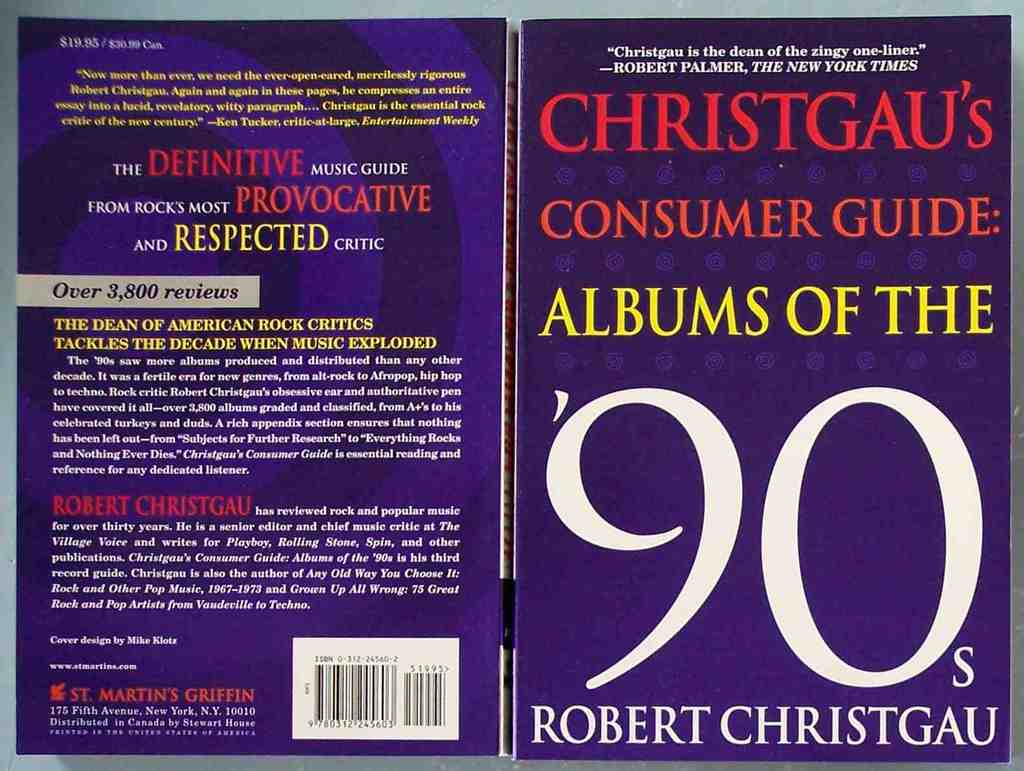What makes the 1990s music scene so significant according to this book? According to Robert Christgau's guide, the 1990s music scene was notable for its explosive diversity and innovation. The decade saw a significant increase in music production and distribution, a result of technological advancements and changing consumer habits. The guide highlights the blending of genres, emergence of new subgenres, and the influential roles of both iconic and underground artists. Christgau's reviews offer a critical overview of these dynamics, providing readers with contextual insights into how the 90s shaped contemporary music trends. 